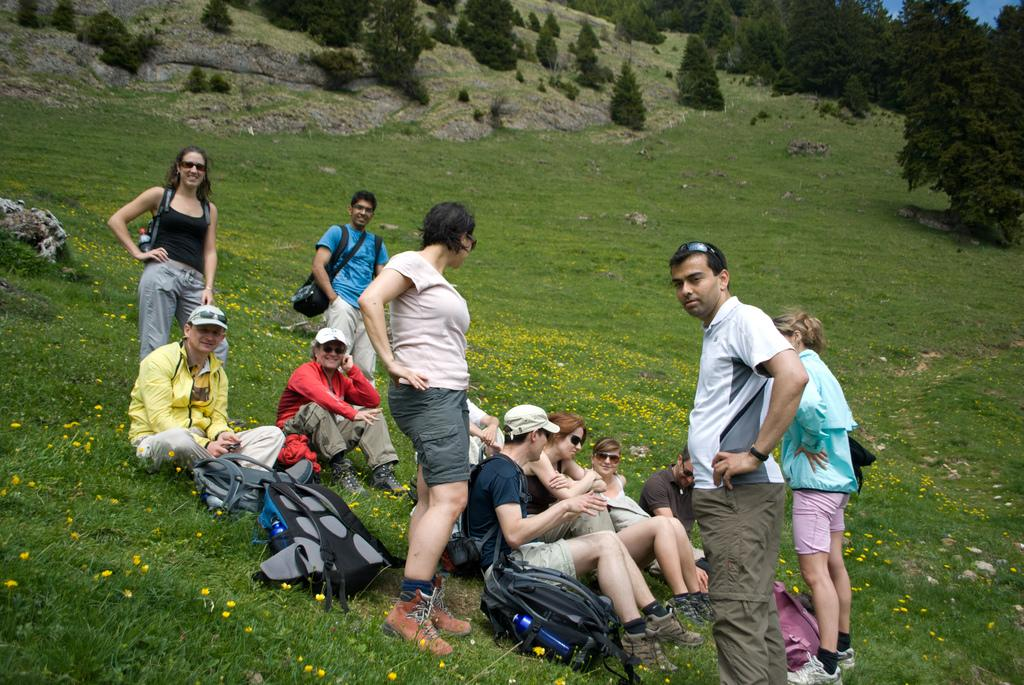What objects are present in the image? There are bags, grass, and flowers in the image. What are the people in the image doing? There are people sitting and standing in the image. What type of vegetation can be seen in the distance? There are trees visible in the distance. Can you see any jellyfish swimming in the grass in the image? No, there are no jellyfish present in the image, and jellyfish cannot swim in grass. Is there a pig visible in the image? No, there is no pig present in the image. 